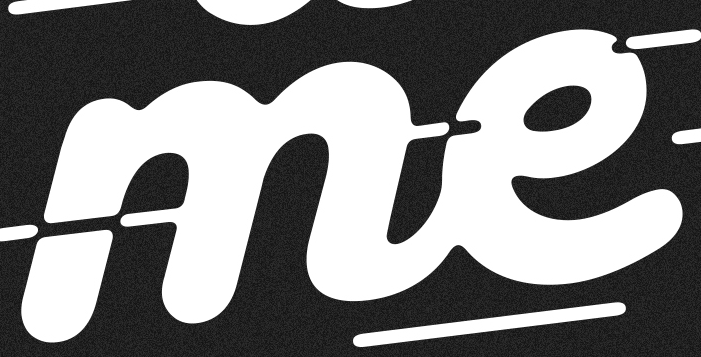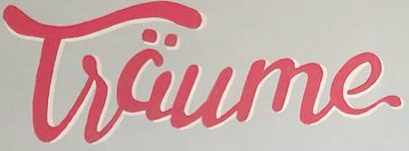What words are shown in these images in order, separated by a semicolon? me; Tsäume 